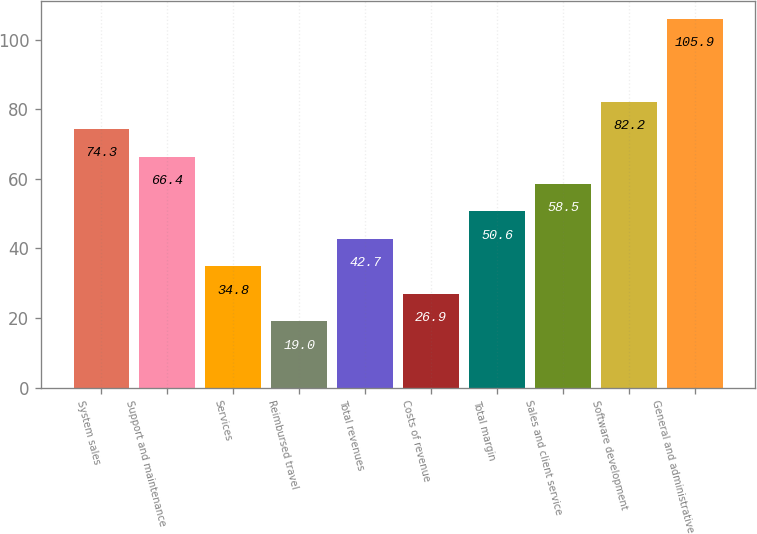Convert chart to OTSL. <chart><loc_0><loc_0><loc_500><loc_500><bar_chart><fcel>System sales<fcel>Support and maintenance<fcel>Services<fcel>Reimbursed travel<fcel>Total revenues<fcel>Costs of revenue<fcel>Total margin<fcel>Sales and client service<fcel>Software development<fcel>General and administrative<nl><fcel>74.3<fcel>66.4<fcel>34.8<fcel>19<fcel>42.7<fcel>26.9<fcel>50.6<fcel>58.5<fcel>82.2<fcel>105.9<nl></chart> 